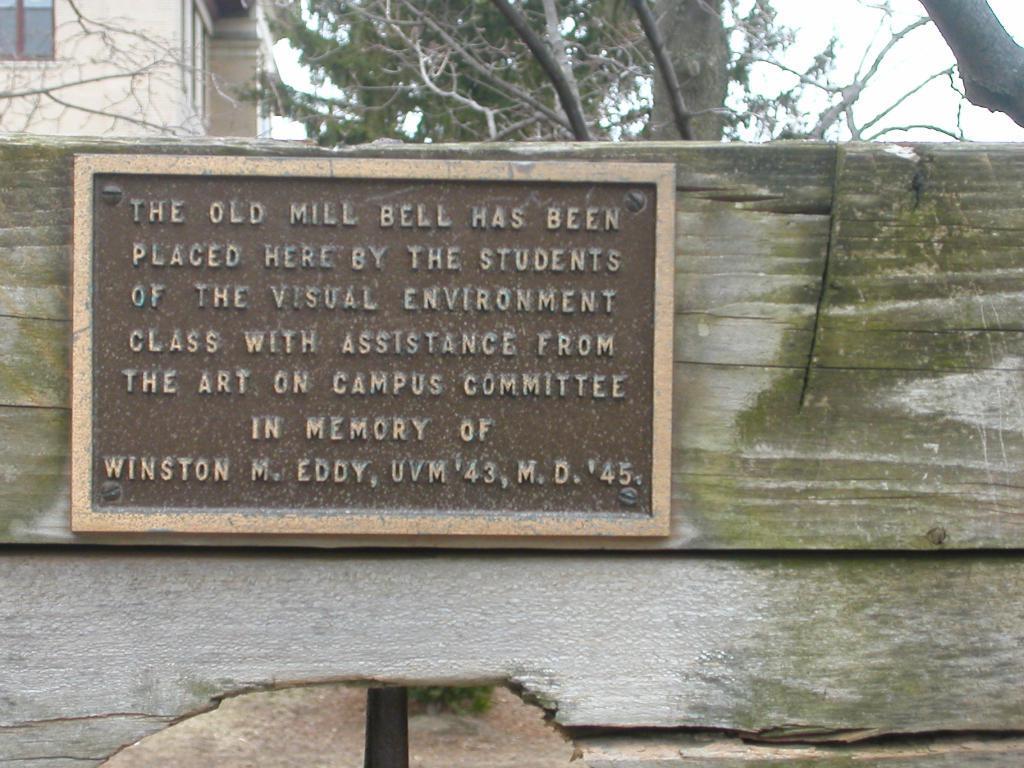Could you give a brief overview of what you see in this image? In the foreground of the image we can see a name board placed on the wood. In the background we can see group of trees ,building and sky. 